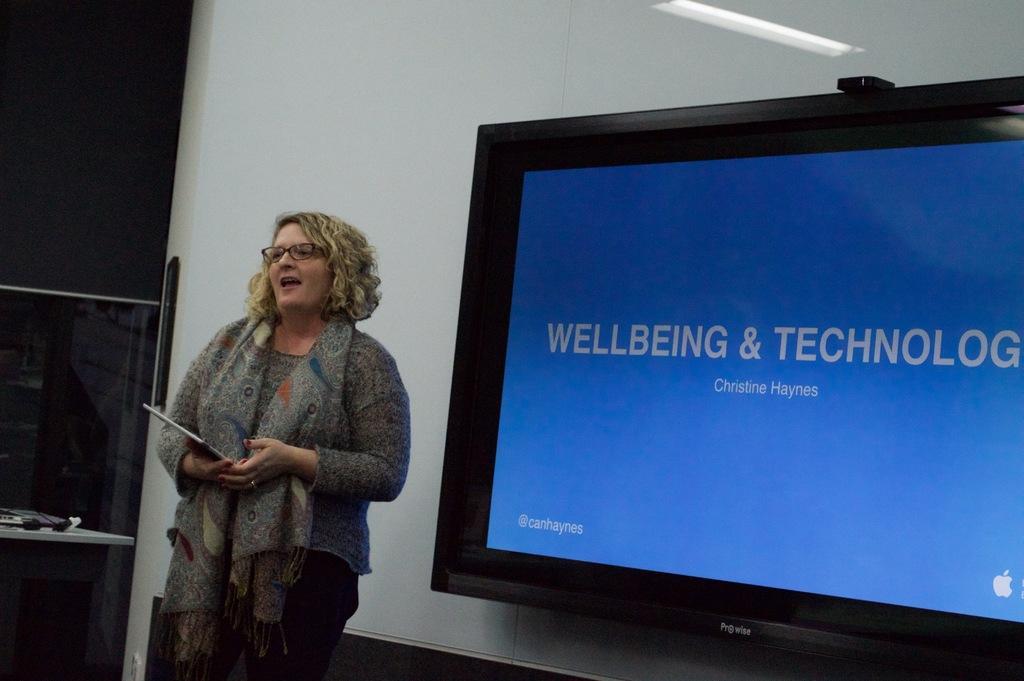In one or two sentences, can you explain what this image depicts? In this image we can see a woman holding an object and standing. We can also see a television screen, wall and also a table and on the table we can see some objects. 